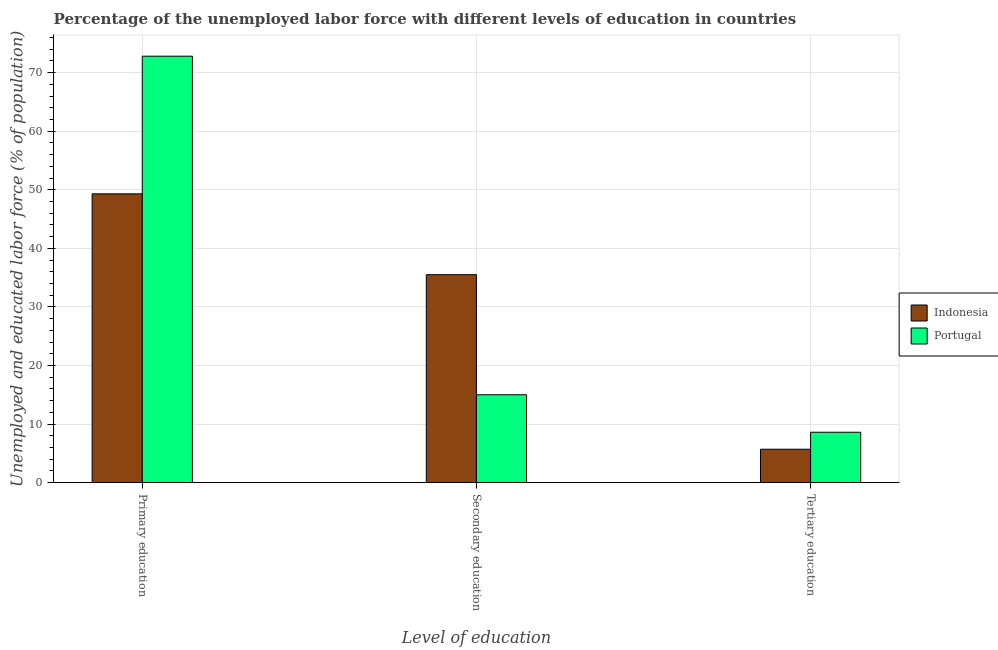How many different coloured bars are there?
Keep it short and to the point. 2. How many groups of bars are there?
Offer a terse response. 3. How many bars are there on the 2nd tick from the left?
Offer a very short reply. 2. How many bars are there on the 3rd tick from the right?
Provide a short and direct response. 2. What is the percentage of labor force who received secondary education in Portugal?
Keep it short and to the point. 15. Across all countries, what is the maximum percentage of labor force who received secondary education?
Keep it short and to the point. 35.5. Across all countries, what is the minimum percentage of labor force who received tertiary education?
Your answer should be compact. 5.7. In which country was the percentage of labor force who received primary education minimum?
Keep it short and to the point. Indonesia. What is the total percentage of labor force who received tertiary education in the graph?
Keep it short and to the point. 14.3. What is the difference between the percentage of labor force who received primary education in Portugal and that in Indonesia?
Give a very brief answer. 23.5. What is the difference between the percentage of labor force who received secondary education in Portugal and the percentage of labor force who received tertiary education in Indonesia?
Provide a short and direct response. 9.3. What is the average percentage of labor force who received tertiary education per country?
Your answer should be compact. 7.15. What is the difference between the percentage of labor force who received primary education and percentage of labor force who received secondary education in Portugal?
Give a very brief answer. 57.8. What is the ratio of the percentage of labor force who received primary education in Portugal to that in Indonesia?
Your response must be concise. 1.48. Is the percentage of labor force who received tertiary education in Portugal less than that in Indonesia?
Your answer should be very brief. No. What is the difference between the highest and the second highest percentage of labor force who received secondary education?
Provide a short and direct response. 20.5. What is the difference between the highest and the lowest percentage of labor force who received primary education?
Offer a terse response. 23.5. In how many countries, is the percentage of labor force who received primary education greater than the average percentage of labor force who received primary education taken over all countries?
Provide a succinct answer. 1. What does the 1st bar from the right in Secondary education represents?
Offer a very short reply. Portugal. Is it the case that in every country, the sum of the percentage of labor force who received primary education and percentage of labor force who received secondary education is greater than the percentage of labor force who received tertiary education?
Your response must be concise. Yes. Are all the bars in the graph horizontal?
Keep it short and to the point. No. What is the difference between two consecutive major ticks on the Y-axis?
Your answer should be compact. 10. Does the graph contain any zero values?
Ensure brevity in your answer.  No. Where does the legend appear in the graph?
Your response must be concise. Center right. What is the title of the graph?
Your answer should be very brief. Percentage of the unemployed labor force with different levels of education in countries. Does "Slovenia" appear as one of the legend labels in the graph?
Your answer should be compact. No. What is the label or title of the X-axis?
Your response must be concise. Level of education. What is the label or title of the Y-axis?
Offer a very short reply. Unemployed and educated labor force (% of population). What is the Unemployed and educated labor force (% of population) of Indonesia in Primary education?
Offer a terse response. 49.3. What is the Unemployed and educated labor force (% of population) of Portugal in Primary education?
Give a very brief answer. 72.8. What is the Unemployed and educated labor force (% of population) of Indonesia in Secondary education?
Your answer should be compact. 35.5. What is the Unemployed and educated labor force (% of population) in Portugal in Secondary education?
Give a very brief answer. 15. What is the Unemployed and educated labor force (% of population) in Indonesia in Tertiary education?
Offer a very short reply. 5.7. What is the Unemployed and educated labor force (% of population) of Portugal in Tertiary education?
Offer a terse response. 8.6. Across all Level of education, what is the maximum Unemployed and educated labor force (% of population) of Indonesia?
Give a very brief answer. 49.3. Across all Level of education, what is the maximum Unemployed and educated labor force (% of population) in Portugal?
Keep it short and to the point. 72.8. Across all Level of education, what is the minimum Unemployed and educated labor force (% of population) in Indonesia?
Provide a succinct answer. 5.7. Across all Level of education, what is the minimum Unemployed and educated labor force (% of population) in Portugal?
Offer a very short reply. 8.6. What is the total Unemployed and educated labor force (% of population) in Indonesia in the graph?
Your response must be concise. 90.5. What is the total Unemployed and educated labor force (% of population) of Portugal in the graph?
Your answer should be very brief. 96.4. What is the difference between the Unemployed and educated labor force (% of population) in Indonesia in Primary education and that in Secondary education?
Keep it short and to the point. 13.8. What is the difference between the Unemployed and educated labor force (% of population) of Portugal in Primary education and that in Secondary education?
Your answer should be compact. 57.8. What is the difference between the Unemployed and educated labor force (% of population) of Indonesia in Primary education and that in Tertiary education?
Ensure brevity in your answer.  43.6. What is the difference between the Unemployed and educated labor force (% of population) of Portugal in Primary education and that in Tertiary education?
Provide a succinct answer. 64.2. What is the difference between the Unemployed and educated labor force (% of population) of Indonesia in Secondary education and that in Tertiary education?
Your answer should be compact. 29.8. What is the difference between the Unemployed and educated labor force (% of population) of Indonesia in Primary education and the Unemployed and educated labor force (% of population) of Portugal in Secondary education?
Give a very brief answer. 34.3. What is the difference between the Unemployed and educated labor force (% of population) in Indonesia in Primary education and the Unemployed and educated labor force (% of population) in Portugal in Tertiary education?
Offer a very short reply. 40.7. What is the difference between the Unemployed and educated labor force (% of population) in Indonesia in Secondary education and the Unemployed and educated labor force (% of population) in Portugal in Tertiary education?
Your answer should be compact. 26.9. What is the average Unemployed and educated labor force (% of population) of Indonesia per Level of education?
Offer a terse response. 30.17. What is the average Unemployed and educated labor force (% of population) in Portugal per Level of education?
Offer a terse response. 32.13. What is the difference between the Unemployed and educated labor force (% of population) of Indonesia and Unemployed and educated labor force (% of population) of Portugal in Primary education?
Provide a short and direct response. -23.5. What is the ratio of the Unemployed and educated labor force (% of population) in Indonesia in Primary education to that in Secondary education?
Give a very brief answer. 1.39. What is the ratio of the Unemployed and educated labor force (% of population) of Portugal in Primary education to that in Secondary education?
Make the answer very short. 4.85. What is the ratio of the Unemployed and educated labor force (% of population) in Indonesia in Primary education to that in Tertiary education?
Your answer should be compact. 8.65. What is the ratio of the Unemployed and educated labor force (% of population) in Portugal in Primary education to that in Tertiary education?
Make the answer very short. 8.47. What is the ratio of the Unemployed and educated labor force (% of population) of Indonesia in Secondary education to that in Tertiary education?
Offer a very short reply. 6.23. What is the ratio of the Unemployed and educated labor force (% of population) in Portugal in Secondary education to that in Tertiary education?
Give a very brief answer. 1.74. What is the difference between the highest and the second highest Unemployed and educated labor force (% of population) in Indonesia?
Provide a succinct answer. 13.8. What is the difference between the highest and the second highest Unemployed and educated labor force (% of population) in Portugal?
Provide a short and direct response. 57.8. What is the difference between the highest and the lowest Unemployed and educated labor force (% of population) of Indonesia?
Keep it short and to the point. 43.6. What is the difference between the highest and the lowest Unemployed and educated labor force (% of population) of Portugal?
Ensure brevity in your answer.  64.2. 